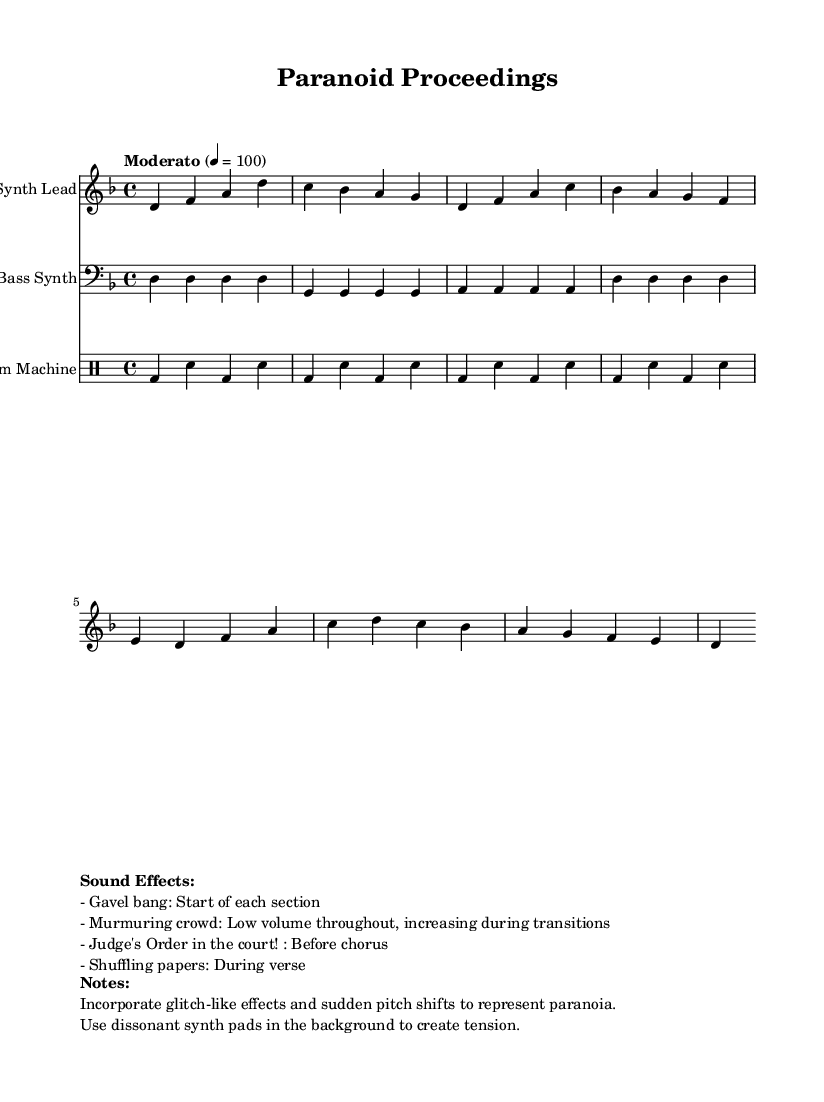What is the key signature of this music? The key signature is indicated as D minor, which has one flat (B flat).
Answer: D minor What is the time signature of this piece? The time signature is shown at the beginning of the score, which is 4/4, meaning there are four beats per measure.
Answer: 4/4 What is the tempo marking of this composition? The tempo marking is provided as "Moderato," specifying a moderate speed. In addition, it is accompanied by a metronome mark of 100 beats per minute.
Answer: Moderato What effect accompanies the start of each section? The gavel bang sound effect is noted as happening at the start of each section, which is explicitly listed in the markup.
Answer: Gavel bang How does the crowd sound contribute to the music? The murmuring crowd is indicated to maintain a low volume throughout the piece but increases during transitions, adding tension to the composition.
Answer: Low volume What is the purpose of the judge's spoken line before the chorus? The phrase "Order in the court!" is specified to be used before the chorus, enhancing the courtroom theme and marking a significant moment before the increase in intensity.
Answer: Order in the court! What type of musical effects are incorporated to represent paranoia? The notes mention the use of glitch-like effects and sudden pitch shifts, which contribute to creating a sense of unease and paranoia in the composition.
Answer: Glitch-like effects 